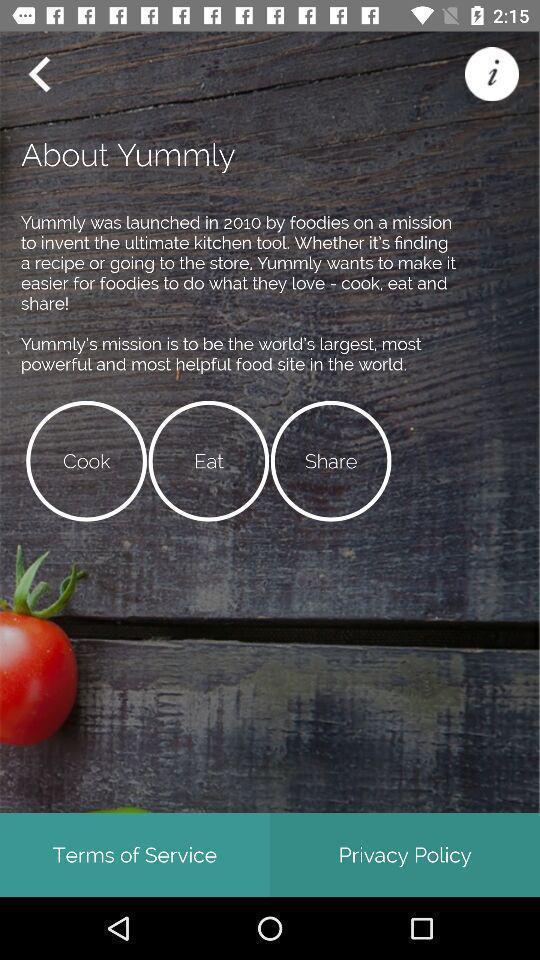Provide a detailed account of this screenshot. Page displaying the information of a food app. 